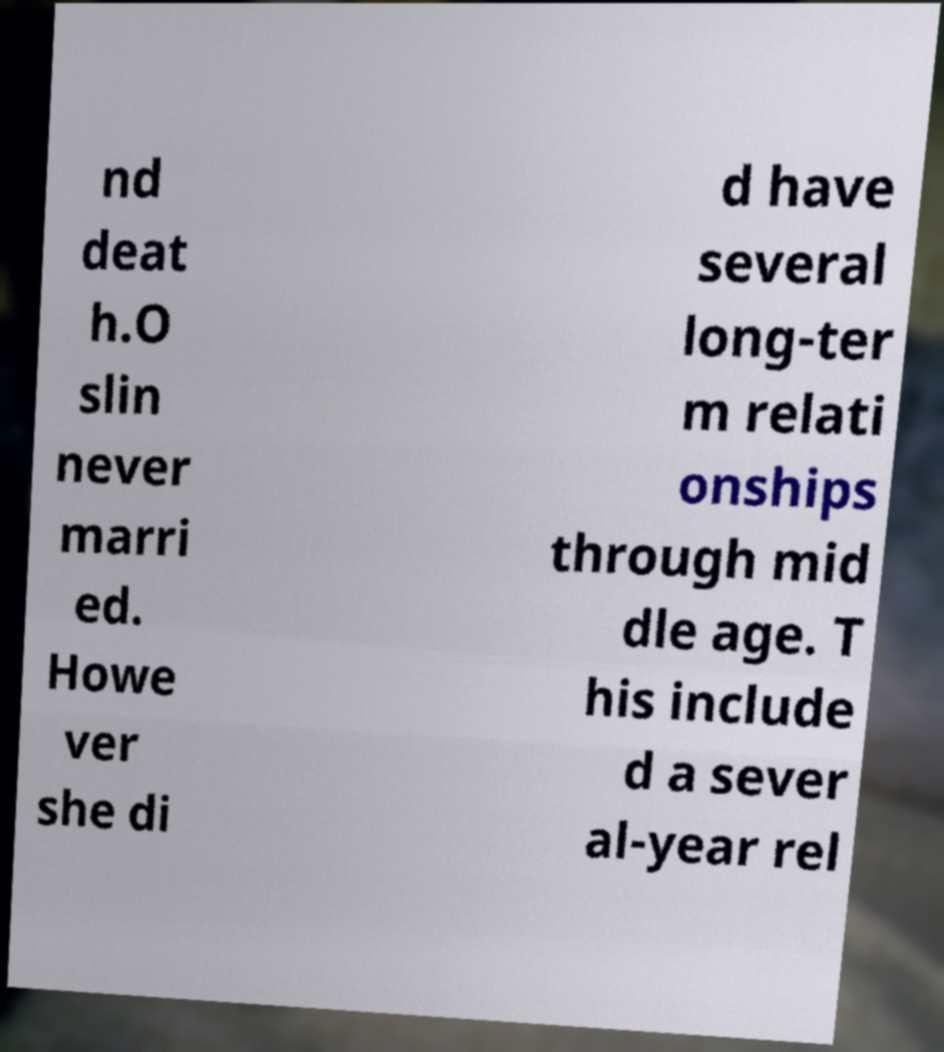I need the written content from this picture converted into text. Can you do that? nd deat h.O slin never marri ed. Howe ver she di d have several long-ter m relati onships through mid dle age. T his include d a sever al-year rel 